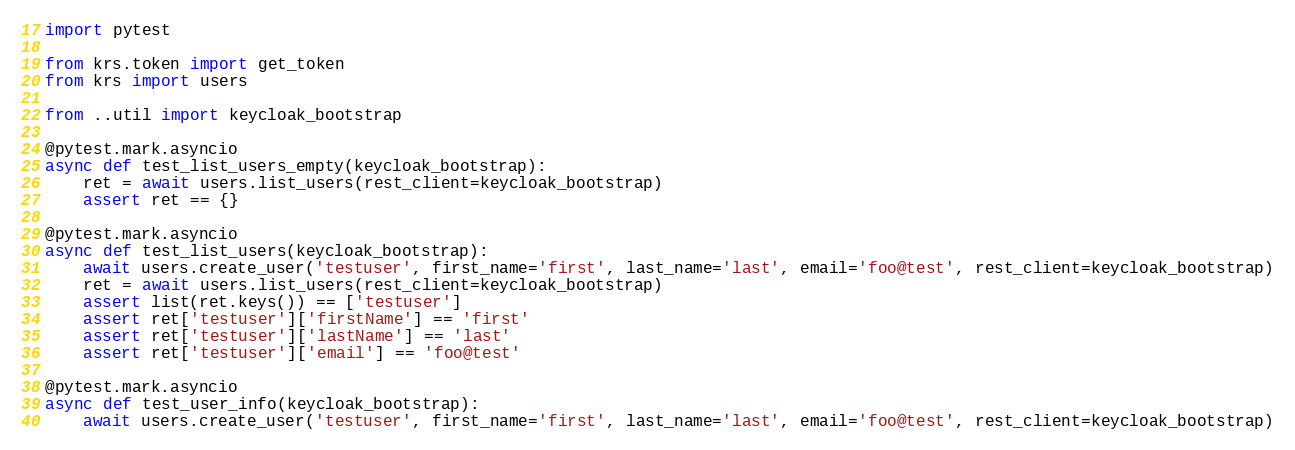Convert code to text. <code><loc_0><loc_0><loc_500><loc_500><_Python_>import pytest

from krs.token import get_token
from krs import users

from ..util import keycloak_bootstrap

@pytest.mark.asyncio
async def test_list_users_empty(keycloak_bootstrap):
    ret = await users.list_users(rest_client=keycloak_bootstrap)
    assert ret == {}

@pytest.mark.asyncio
async def test_list_users(keycloak_bootstrap):
    await users.create_user('testuser', first_name='first', last_name='last', email='foo@test', rest_client=keycloak_bootstrap)
    ret = await users.list_users(rest_client=keycloak_bootstrap)
    assert list(ret.keys()) == ['testuser']
    assert ret['testuser']['firstName'] == 'first'
    assert ret['testuser']['lastName'] == 'last'
    assert ret['testuser']['email'] == 'foo@test'

@pytest.mark.asyncio
async def test_user_info(keycloak_bootstrap):
    await users.create_user('testuser', first_name='first', last_name='last', email='foo@test', rest_client=keycloak_bootstrap)</code> 